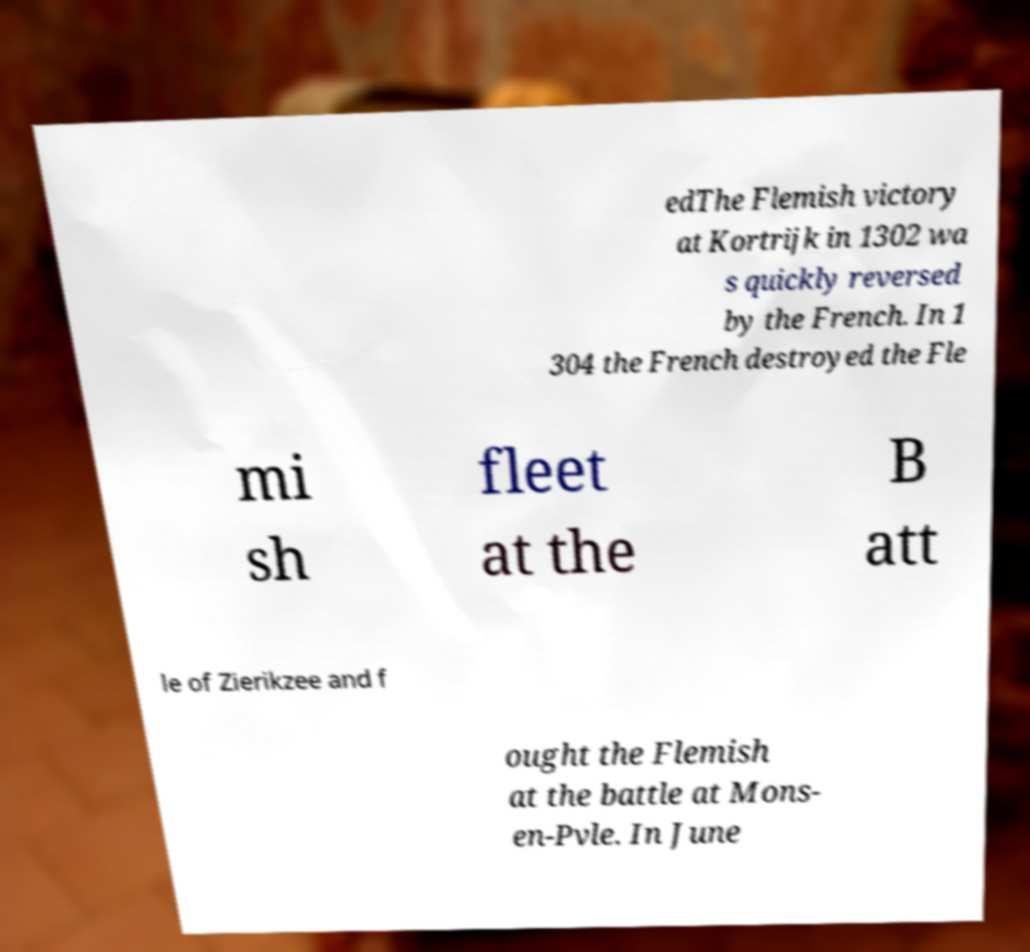Can you accurately transcribe the text from the provided image for me? edThe Flemish victory at Kortrijk in 1302 wa s quickly reversed by the French. In 1 304 the French destroyed the Fle mi sh fleet at the B att le of Zierikzee and f ought the Flemish at the battle at Mons- en-Pvle. In June 